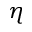Convert formula to latex. <formula><loc_0><loc_0><loc_500><loc_500>\eta</formula> 